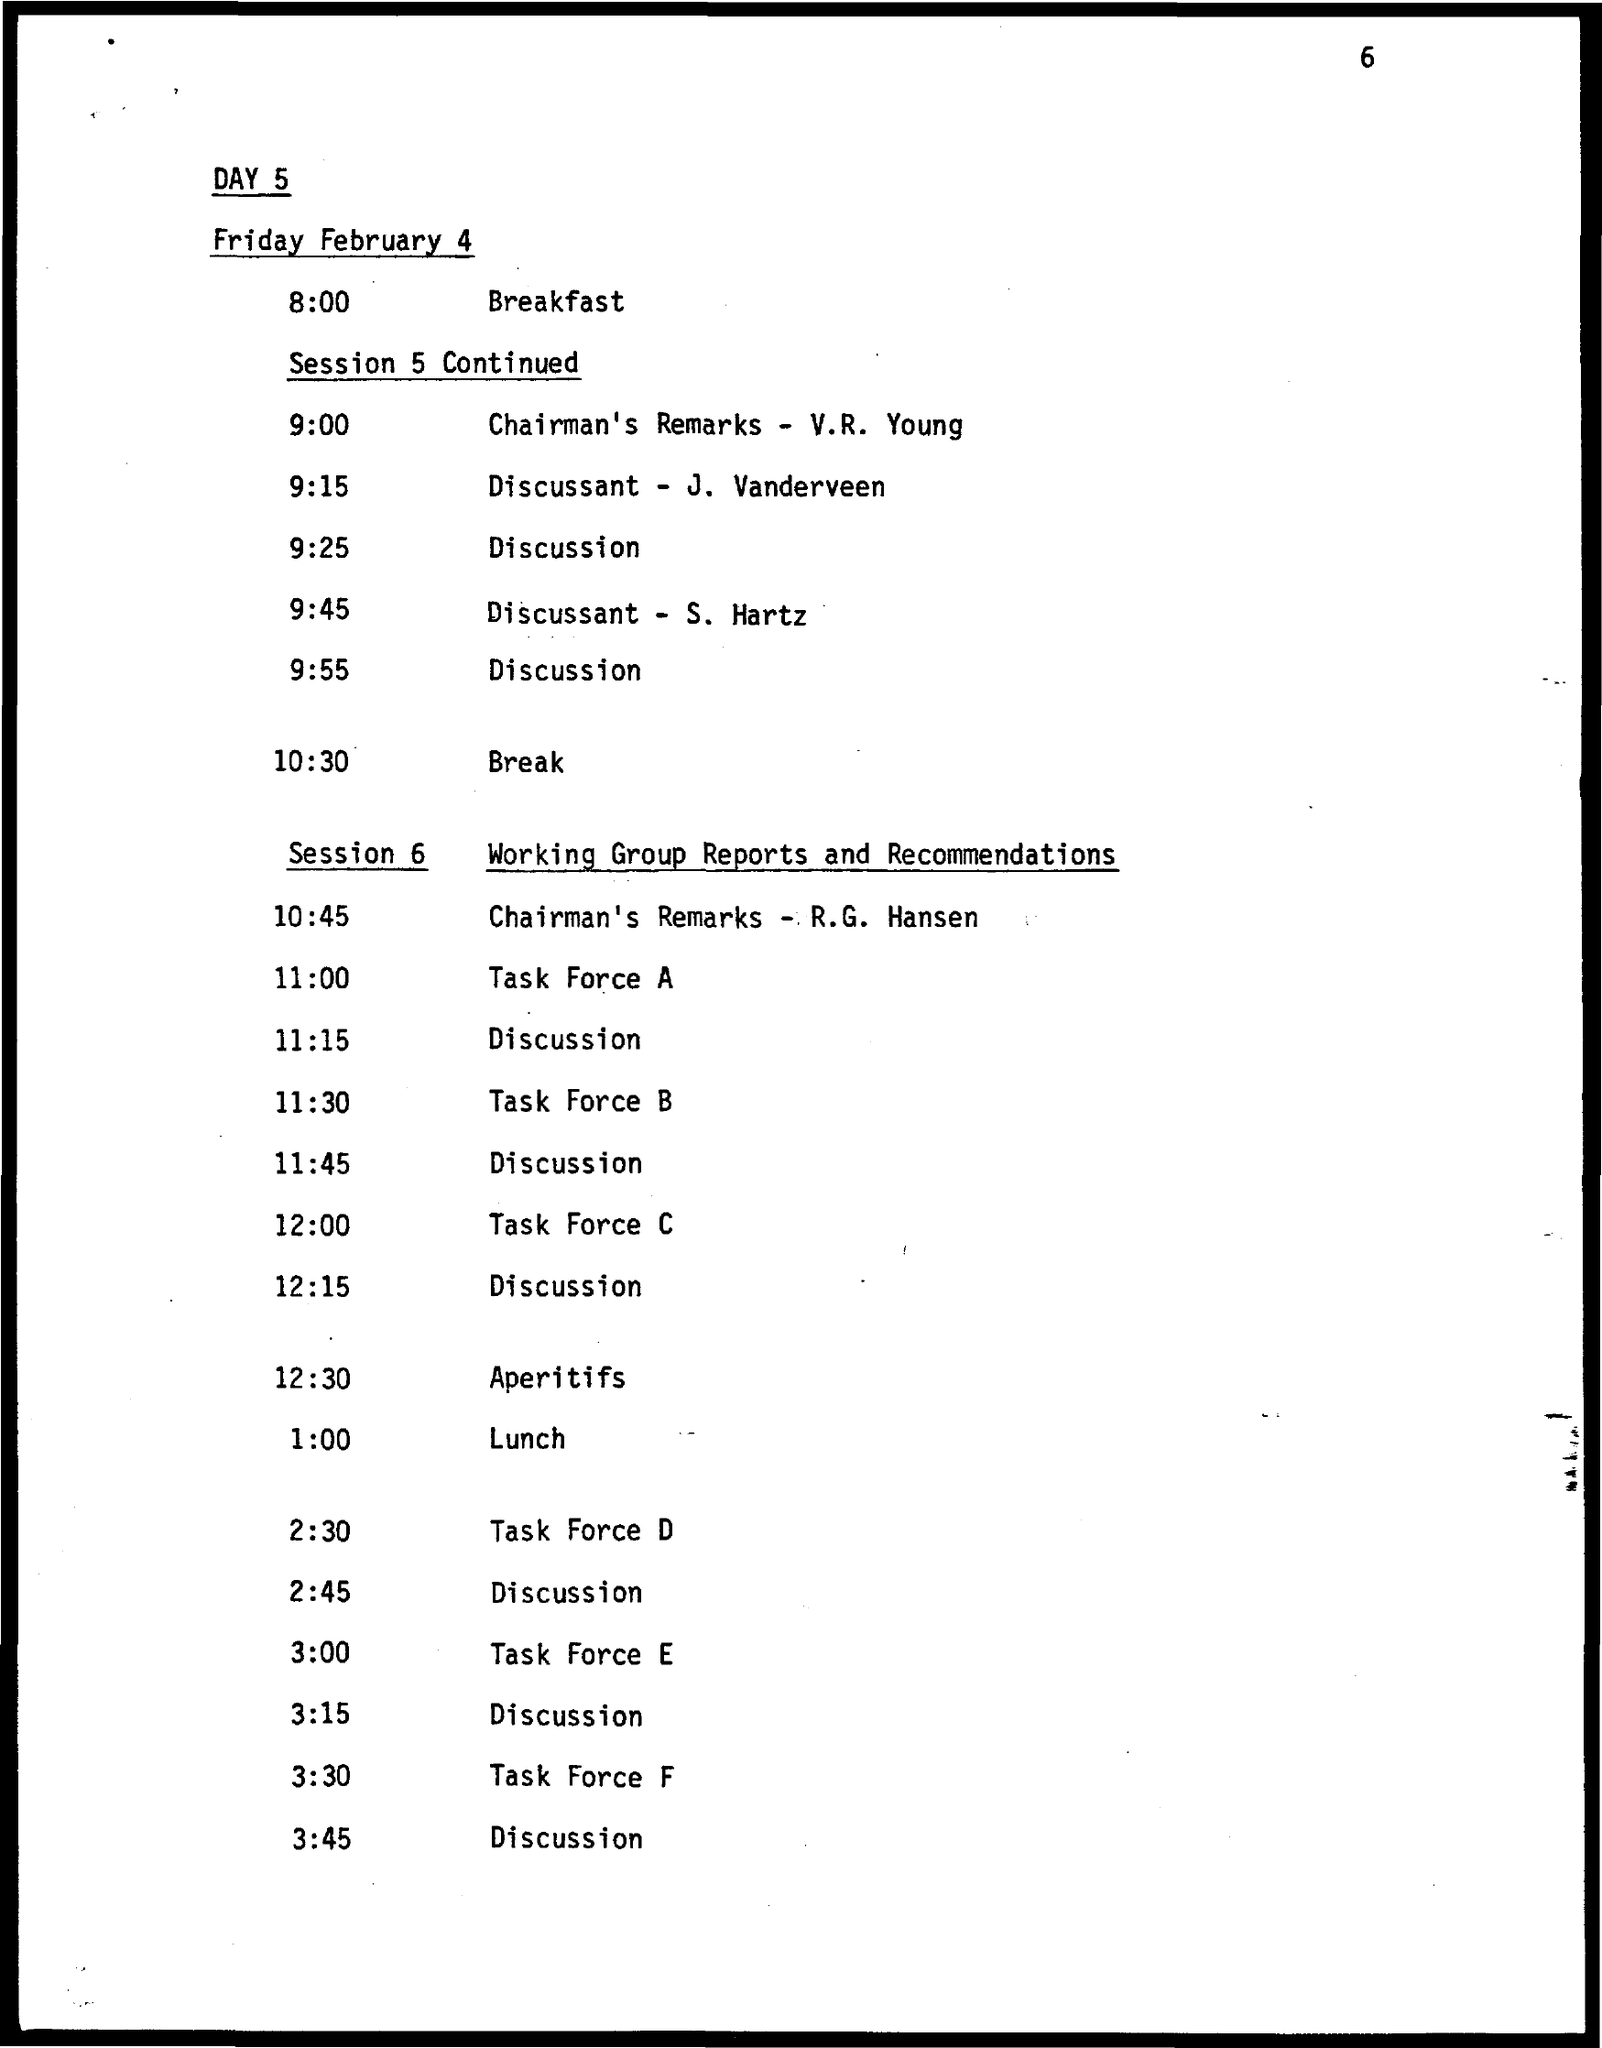What is the date on the document?
Your answer should be compact. FRIDAY FEBRUARY 4. When is Task force A?
Offer a terse response. 11:00. When is Task force B?
Your response must be concise. 11:30. When is Task force C?
Offer a terse response. 12:00. When is Task force D?
Provide a short and direct response. 2:30. When is Task force E?
Provide a succinct answer. 3:00. When is Task force F?
Provide a succinct answer. 3:30. When is Aperitifs?
Keep it short and to the point. 12:30. When is lunch?
Provide a short and direct response. 1:00. 